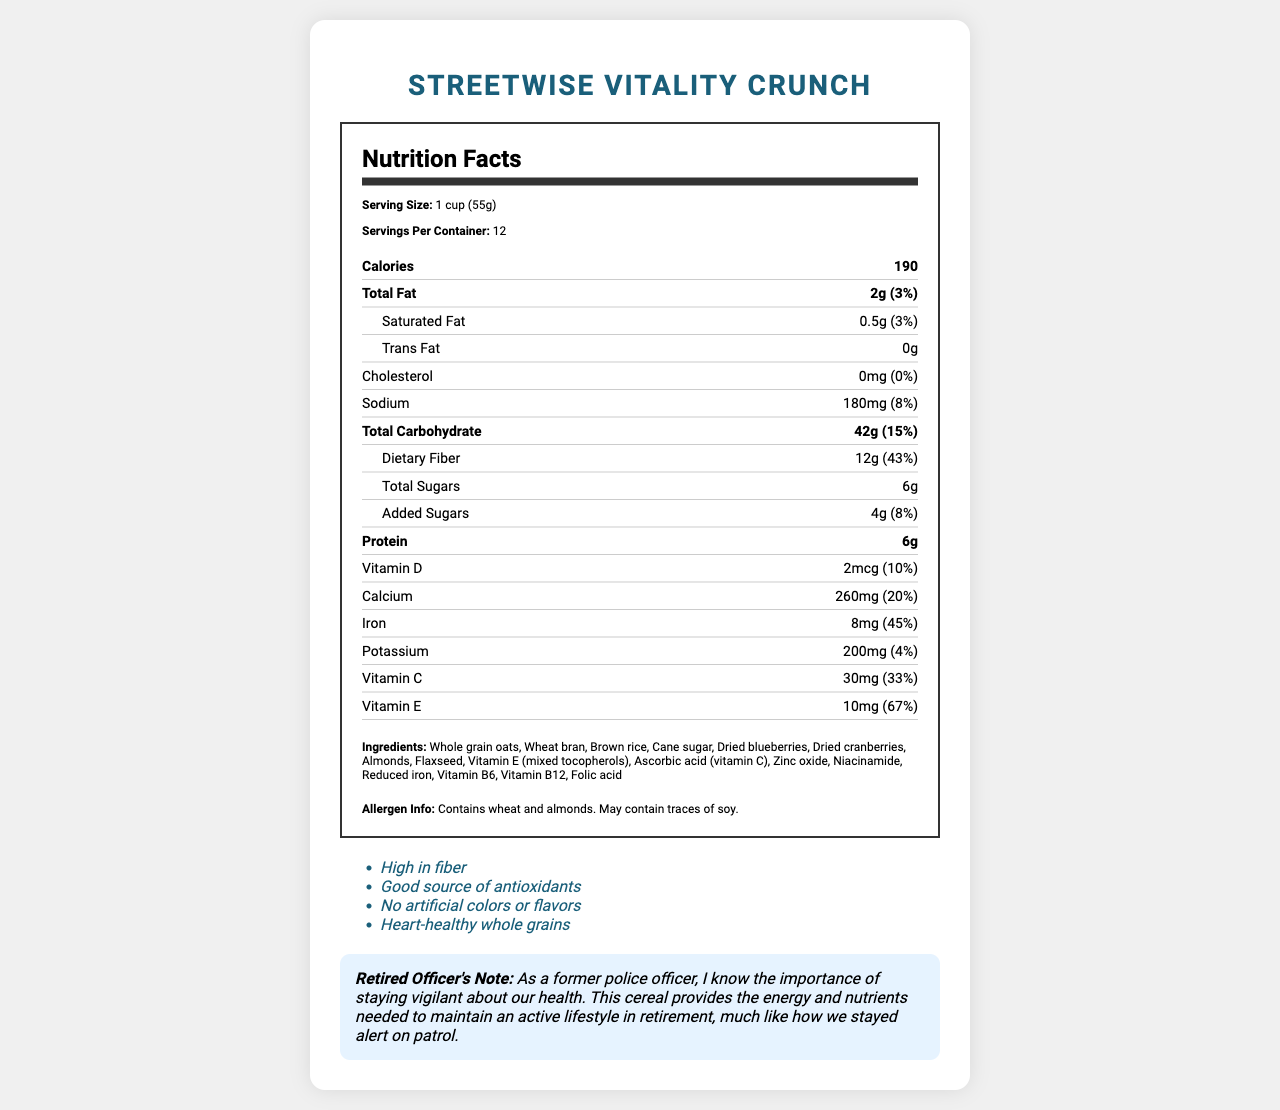how many grams of dietary fiber does one serving of StreetWise Vitality Crunch contain? The document states that one serving of StreetWise Vitality Crunch contains 12 grams of dietary fiber.
Answer: 12g what is the percentage daily value of iron per serving? The document mentions that the iron content per serving has a daily value percentage of 45%.
Answer: 45% what is the serving size of StreetWise Vitality Crunch? The document specifies the serving size as 1 cup (55g).
Answer: 1 cup (55g) list three ingredients in StreetWise Vitality Crunch. The list of ingredients in the document includes whole grain oats, wheat bran, and brown rice.
Answer: Whole grain oats, Wheat bran, Brown rice is there any cholesterol in StreetWise Vitality Crunch? The document indicates that StreetWise Vitality Crunch contains 0mg of cholesterol, amounting to 0% of the daily value.
Answer: No how many calories are there per serving? According to the document, one serving of StreetWise Vitality Crunch contains 190 calories.
Answer: 190 are there any artificial colors or flavors in this cereal? The document claims that StreetWise Vitality Crunch has no artificial colors or flavors.
Answer: No which vitamin has the highest daily value percentage in one serving? 
   A. Vitamin D 
   B. Vitamin E 
   C. Vitamin C 
   D. Calcium The document states that vitamin E has the highest daily value percentage at 67%.
Answer: B. Vitamin E based on the nutrient information, which nutrient is most prevalent in terms of daily value percentage in one serving?
   1. Protein
   2. Dietary Fiber
   3. Added Sugars
   4. Sodium The document reports that dietary fiber has a daily value percentage of 43%, the highest among the listed options.
Answer: 2. Dietary Fiber is this cereal heart-healthy? One of the marketing claims in the document indicates that StreetWise Vitality Crunch is heart-healthy due to its whole grains.
Answer: Yes summarize the key nutritional benefits of StreetWise Vitality Crunch. The document highlights the nutritional benefits of the cereal by listing its high fiber content, antioxidants, lack of artificial additives, and heart-healthy whole grains. It also provides detailed nutrient information, daily values, and ingredient lists.
Answer: StreetWise Vitality Crunch is high in fiber (12g per serving), contains antioxidants (like vitamin E and vitamin C), and is a heart-healthy option with no artificial colors or flavors. It provides substantial daily value percentages for several nutrients, particularly dietary fiber, iron, and vitamins. It also includes ingredients like whole grain oats, wheat bran, and dried fruits, making it a nutritious breakfast choice aimed at maintaining an active lifestyle. how long will one container of StreetWise Vitality Crunch last if I eat one serving every day? Given that the document states there are 12 servings per container, and consuming one serving per day would make the container last for 12 days.
Answer: 12 days does StreetWise Vitality Crunch contain any soy? The document specifies that StreetWise Vitality Crunch may contain traces of soy, which is not certain.
Answer: May contain traces of soy what are the marketing claims of this cereal? The document lists these specific marketing claims indicating the nutritional benefits of the cereal.
Answer: High in fiber, Good source of antioxidants, No artificial colors or flavors, Heart-healthy whole grains can the amount of zinc in StreetWise Vitality Crunch be determined from the document? The document does not mention the zinc content, only listing various vitamins and minerals such as vitamin E, vitamin C, and others.
Answer: Not enough information 